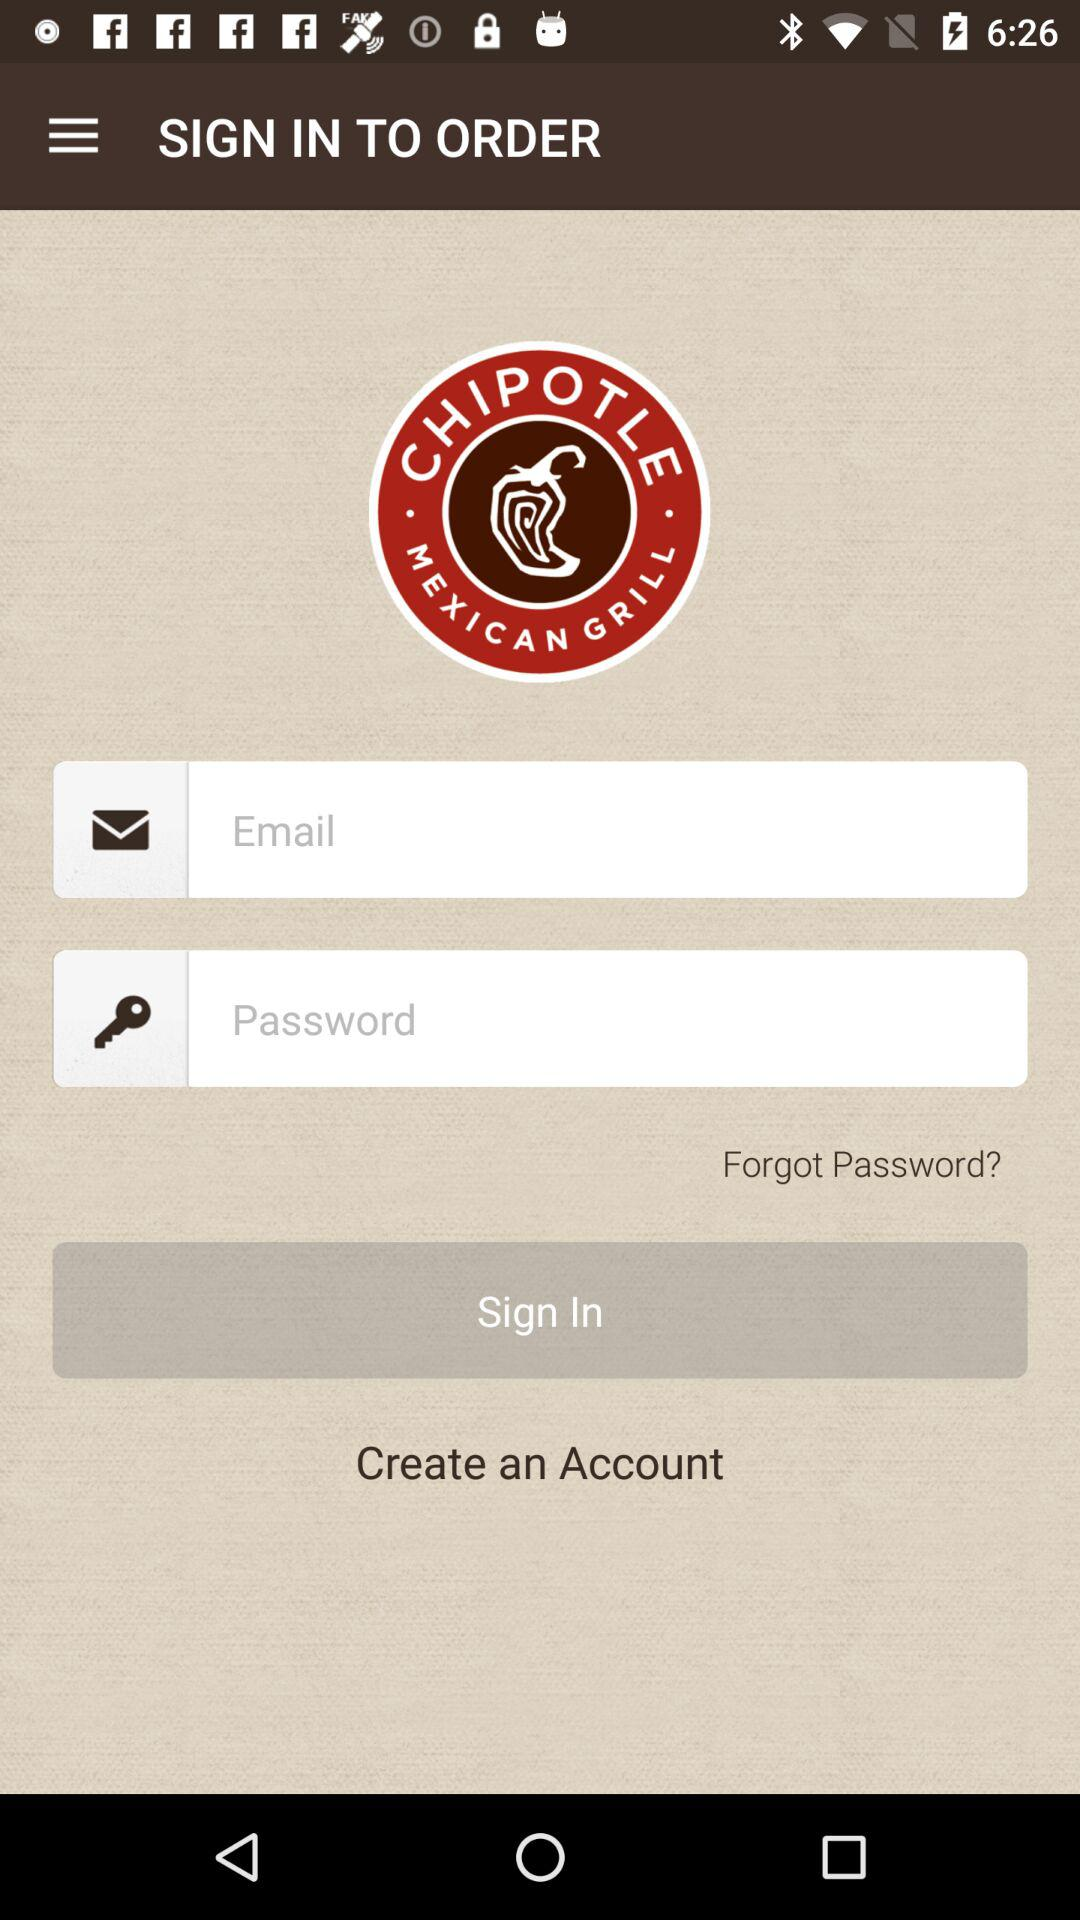What is the app name? The app name is "CHIPOTLE". 